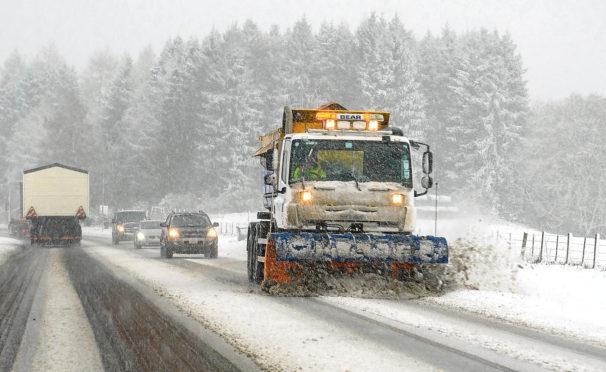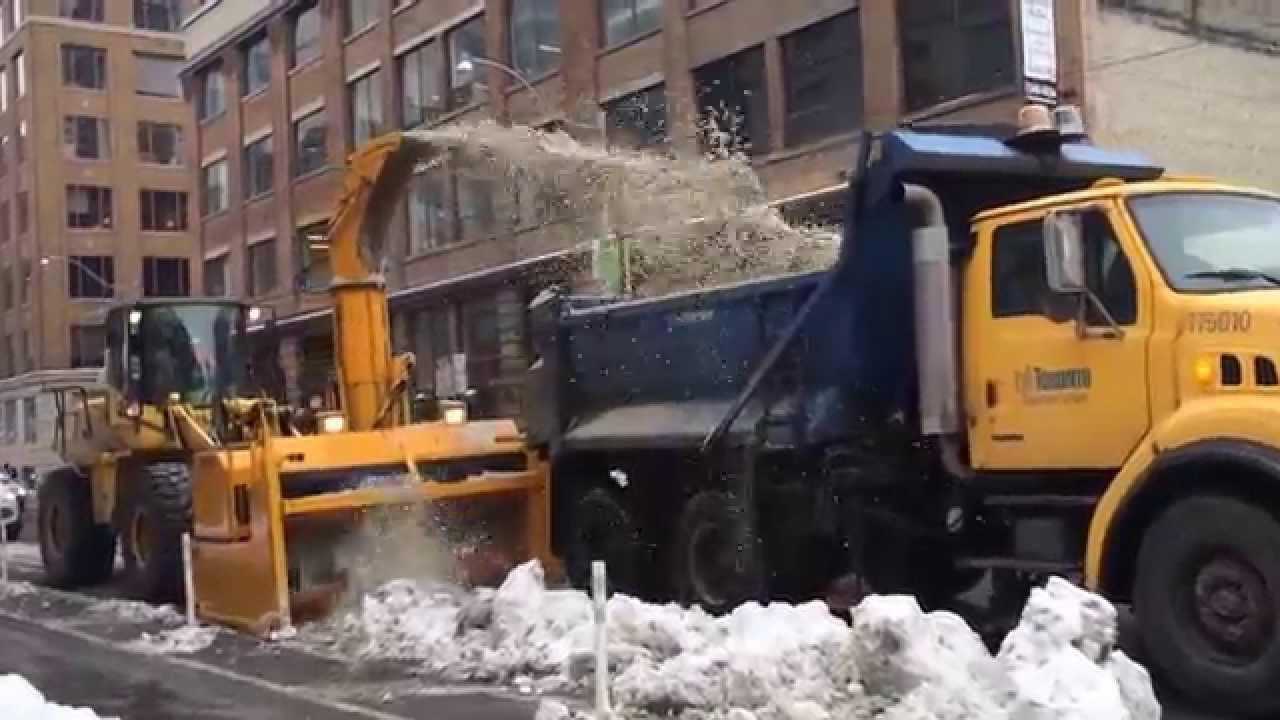The first image is the image on the left, the second image is the image on the right. Evaluate the accuracy of this statement regarding the images: "The truck in one of the images has a red plow.". Is it true? Answer yes or no. No. The first image is the image on the left, the second image is the image on the right. For the images shown, is this caption "There is a snow plow attached to a truck in the left image and a different heavy machinery vehicle in the right image." true? Answer yes or no. Yes. 